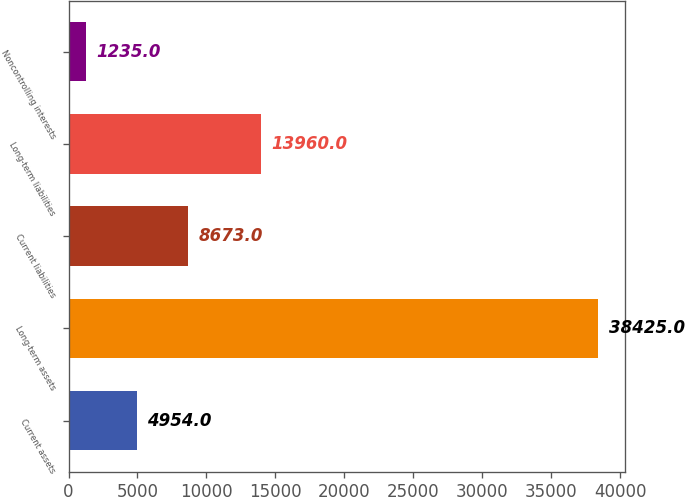Convert chart. <chart><loc_0><loc_0><loc_500><loc_500><bar_chart><fcel>Current assets<fcel>Long-term assets<fcel>Current liabilities<fcel>Long-term liabilities<fcel>Noncontrolling interests<nl><fcel>4954<fcel>38425<fcel>8673<fcel>13960<fcel>1235<nl></chart> 